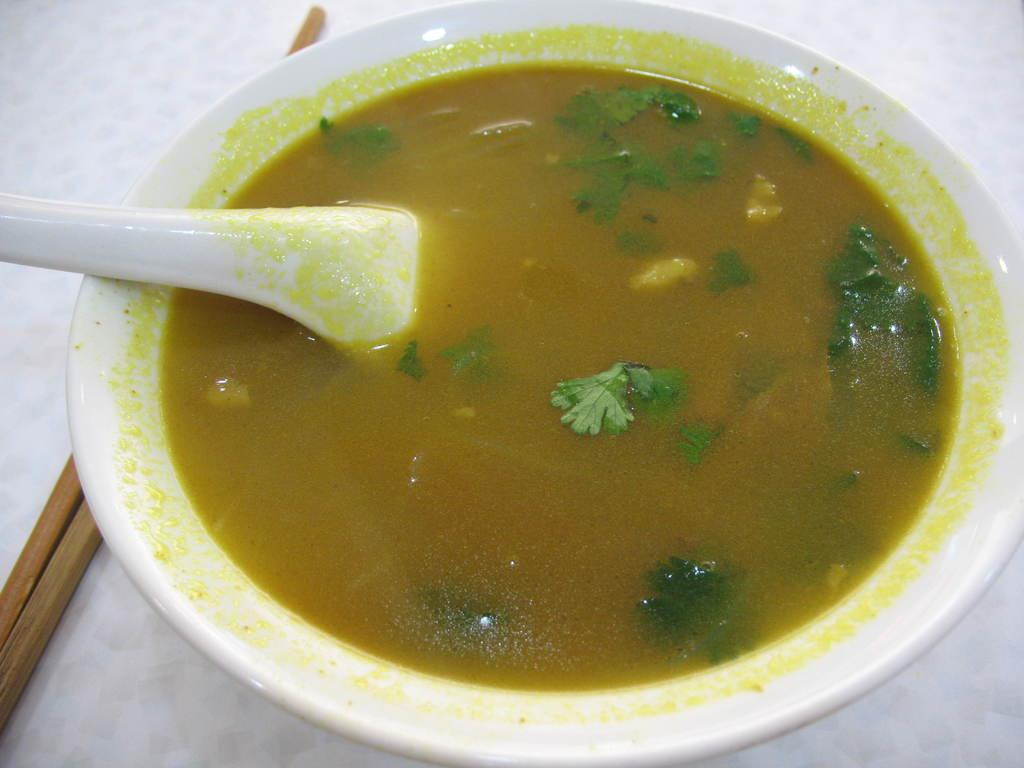What is the main subject in the center of the image? There is soup in the center of the image. What utensil is present in the bowl with the soup? There is a spoon in the bowl with the soup. What can be seen in the background of the image? In the background, there are sticks on the table. What type of oatmeal is being served at the meeting in the image? There is no meeting or oatmeal present in the image; it features a bowl of soup with a spoon. How many pairs of feet can be seen in the image? There are no feet visible in the image. 